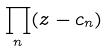<formula> <loc_0><loc_0><loc_500><loc_500>\prod _ { n } ( z - c _ { n } )</formula> 